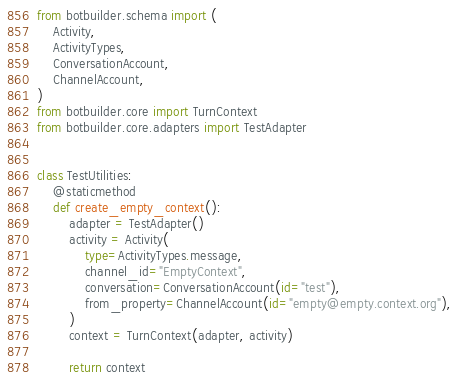Convert code to text. <code><loc_0><loc_0><loc_500><loc_500><_Python_>from botbuilder.schema import (
    Activity,
    ActivityTypes,
    ConversationAccount,
    ChannelAccount,
)
from botbuilder.core import TurnContext
from botbuilder.core.adapters import TestAdapter


class TestUtilities:
    @staticmethod
    def create_empty_context():
        adapter = TestAdapter()
        activity = Activity(
            type=ActivityTypes.message,
            channel_id="EmptyContext",
            conversation=ConversationAccount(id="test"),
            from_property=ChannelAccount(id="empty@empty.context.org"),
        )
        context = TurnContext(adapter, activity)

        return context
</code> 